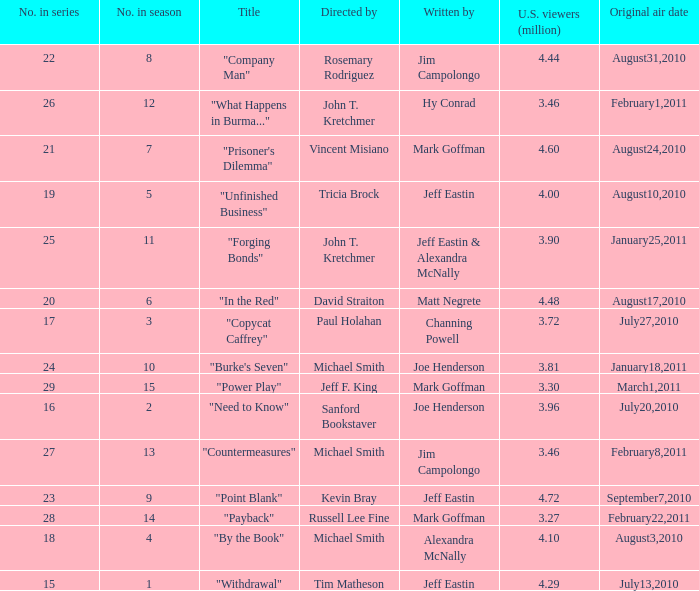Who directed the episode "Point Blank"? Kevin Bray. 